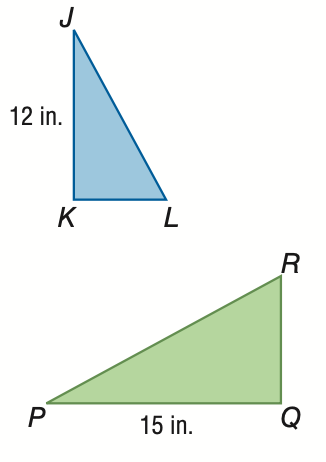Answer the mathemtical geometry problem and directly provide the correct option letter.
Question: If \triangle J K L \sim \triangle P Q R and the area of \triangle J K L is 30 square inches, find the area of \triangle P Q R.
Choices: A: 19.2 B: 24.0 C: 37.5 D: 46.9 D 